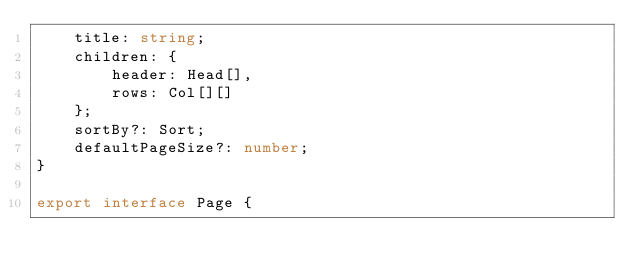Convert code to text. <code><loc_0><loc_0><loc_500><loc_500><_TypeScript_>    title: string;
    children: {
        header: Head[],
        rows: Col[][]
    };
    sortBy?: Sort;
    defaultPageSize?: number;
}

export interface Page {</code> 